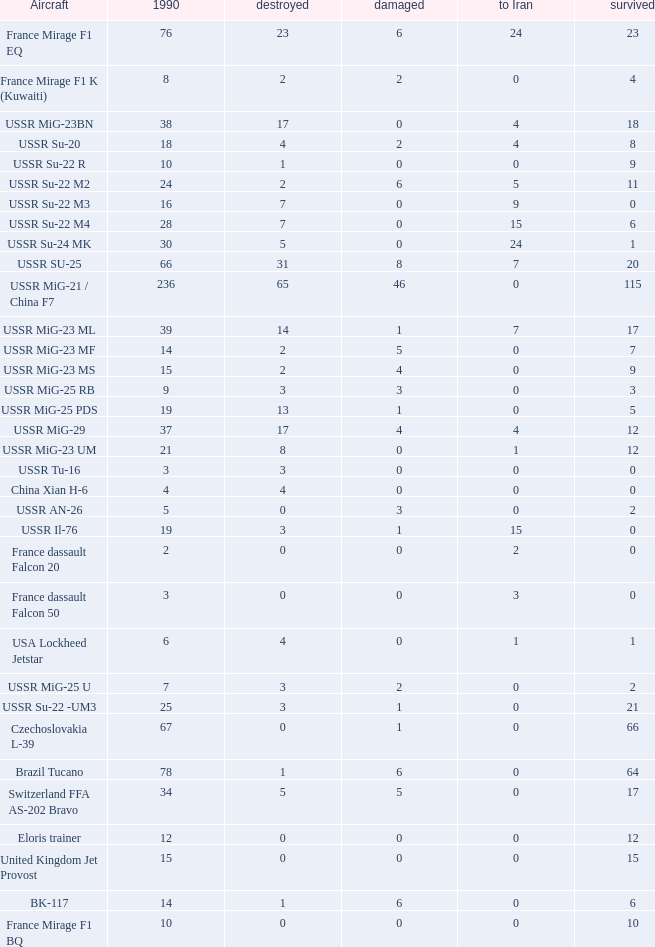If there were 14 in 1990 and 6 survived how many were destroyed? 1.0. 